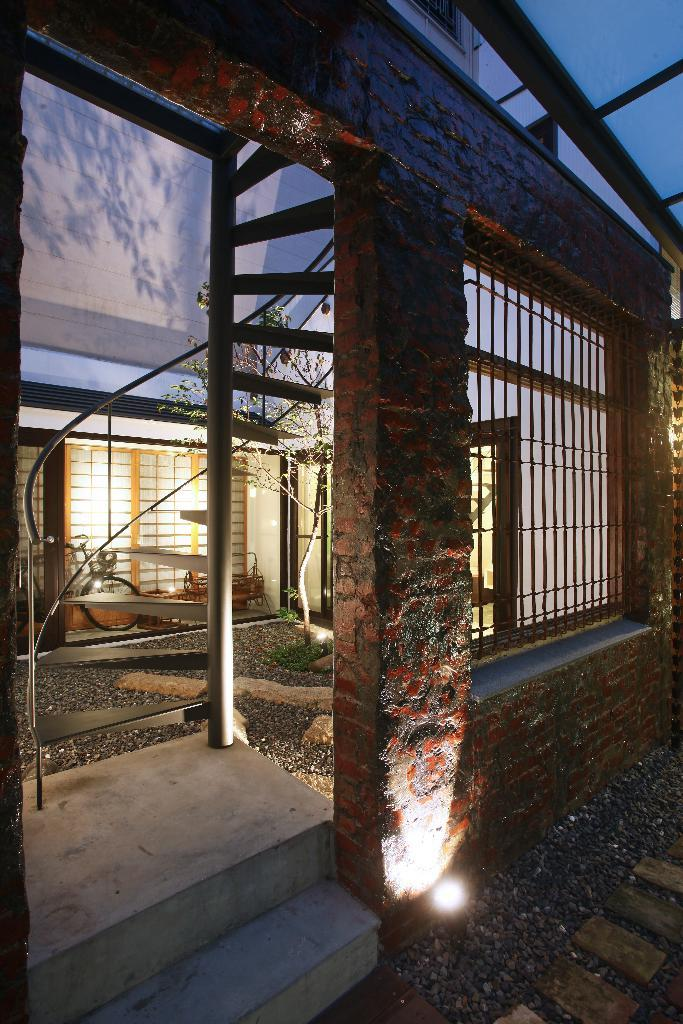What type of plant can be seen in the image? There is a tree in the image. What architectural feature is present in the image? There is a window, a wall, a pillar, steps, and a door in the image. What mode of transportation is visible in the image? There is a bicycle in the image. What part of the natural environment is visible in the image? The sky is visible in the image. How many twigs are attached to the tree in the image? There is no mention of twigs in the provided facts, so it is impossible to determine the number of twigs on the tree in the image. What color is the balloon floating above the bicycle in the image? There is no balloon present in the image. 